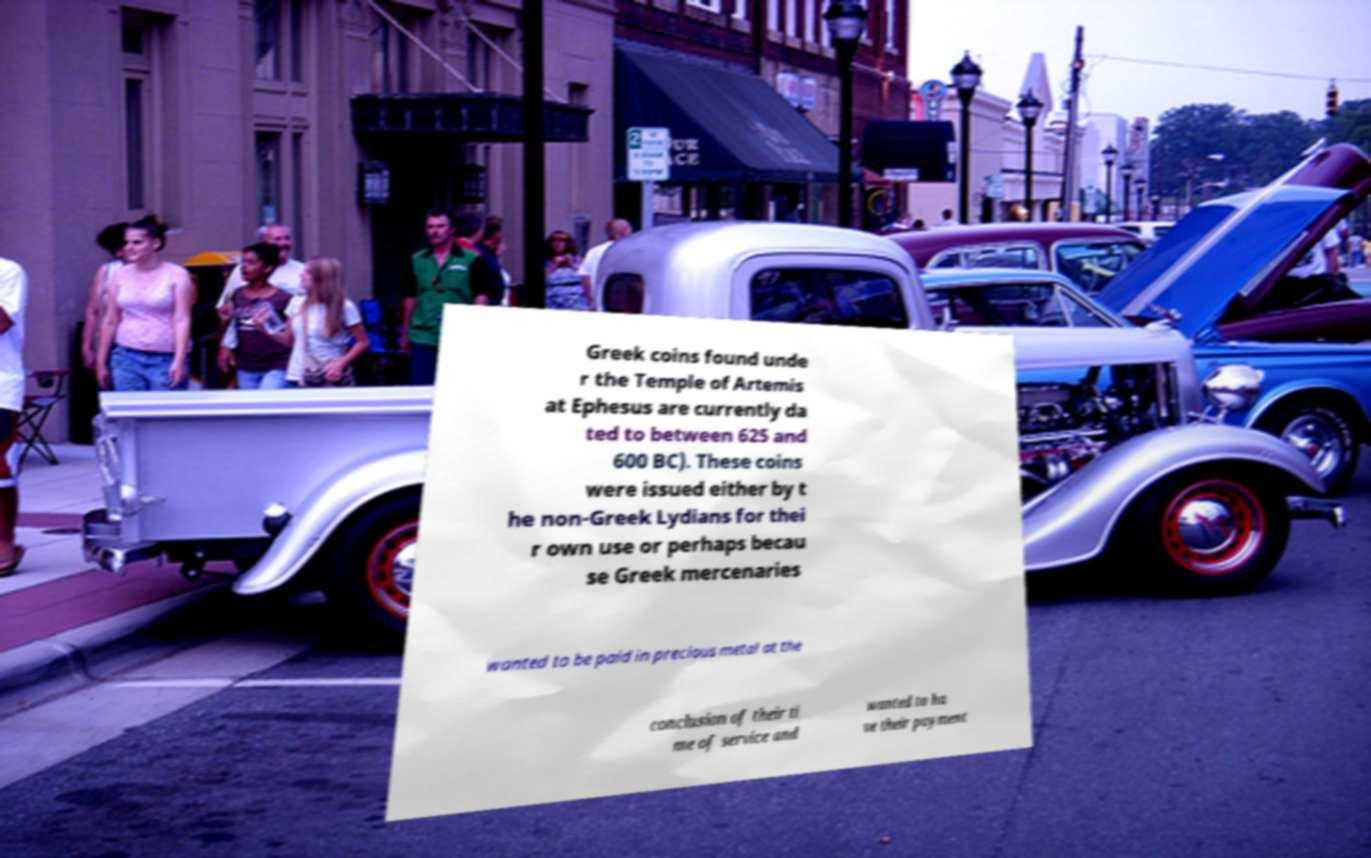Please read and relay the text visible in this image. What does it say? Greek coins found unde r the Temple of Artemis at Ephesus are currently da ted to between 625 and 600 BC). These coins were issued either by t he non-Greek Lydians for thei r own use or perhaps becau se Greek mercenaries wanted to be paid in precious metal at the conclusion of their ti me of service and wanted to ha ve their payment 